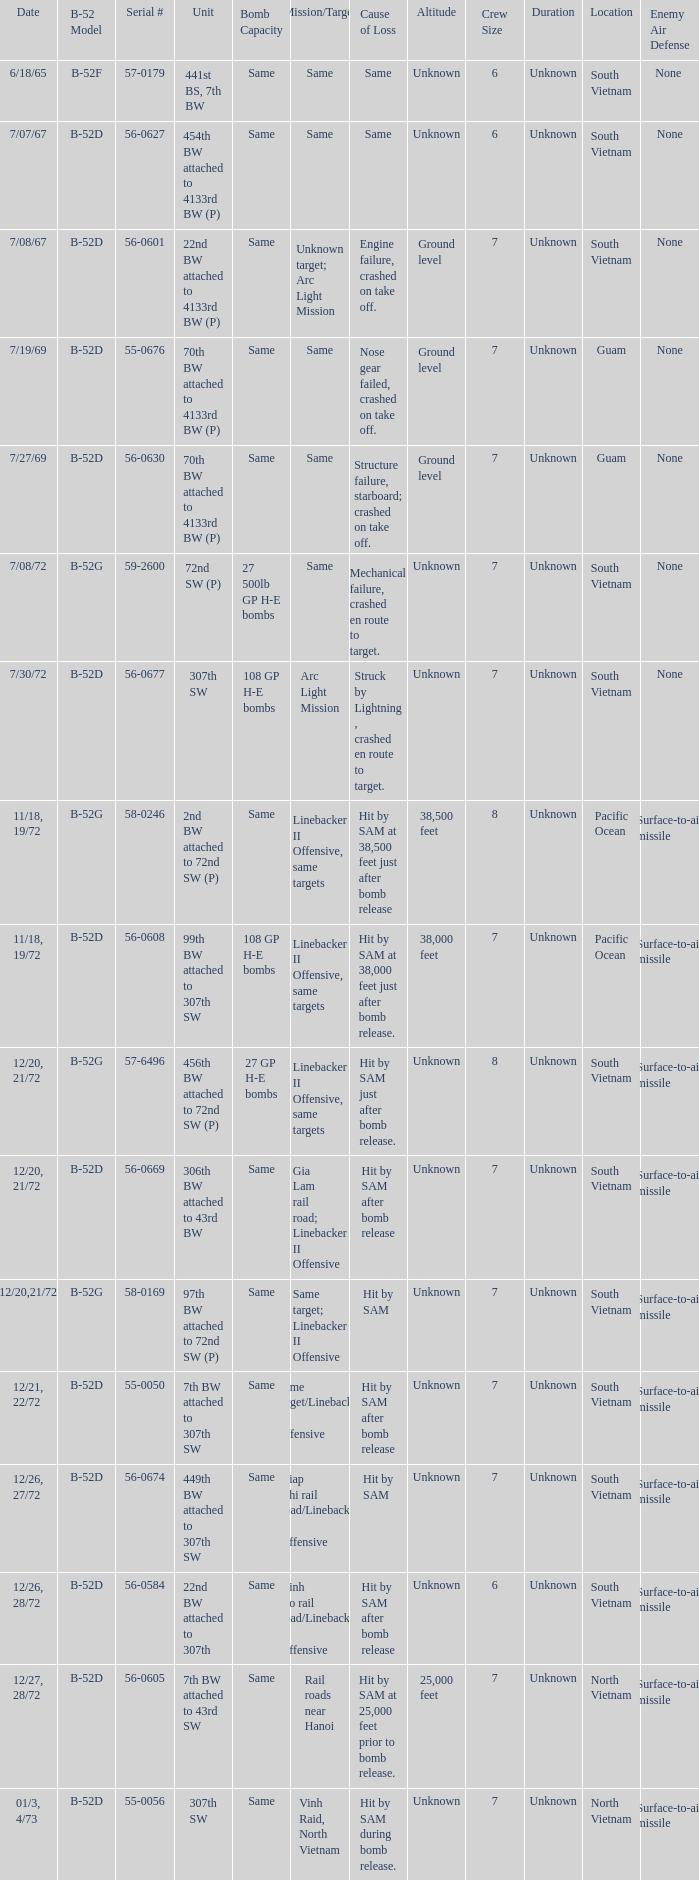When hit by sam at 38,500 feet just after bomb release was the cause of loss what is the mission/target? Linebacker II Offensive, same targets. 